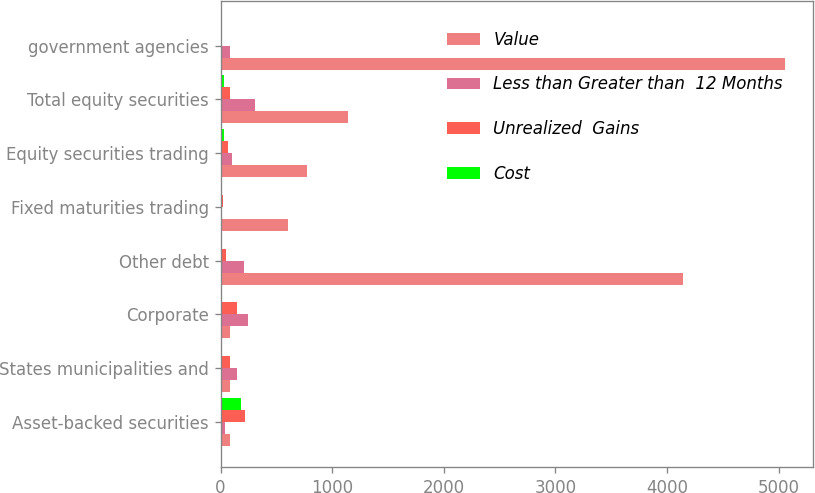Convert chart. <chart><loc_0><loc_0><loc_500><loc_500><stacked_bar_chart><ecel><fcel>Asset-backed securities<fcel>States municipalities and<fcel>Corporate<fcel>Other debt<fcel>Fixed maturities trading<fcel>Equity securities trading<fcel>Total equity securities<fcel>government agencies<nl><fcel>Value<fcel>82<fcel>82<fcel>82<fcel>4143<fcel>604<fcel>777<fcel>1143<fcel>5055<nl><fcel>Less than Greater than  12 Months<fcel>39<fcel>144<fcel>246<fcel>208<fcel>6<fcel>99<fcel>313<fcel>86<nl><fcel>Unrealized  Gains<fcel>223<fcel>82<fcel>149<fcel>48<fcel>19<fcel>69<fcel>81<fcel>2<nl><fcel>Cost<fcel>183<fcel>2<fcel>12<fcel>4<fcel>9<fcel>28<fcel>28<fcel>1<nl></chart> 